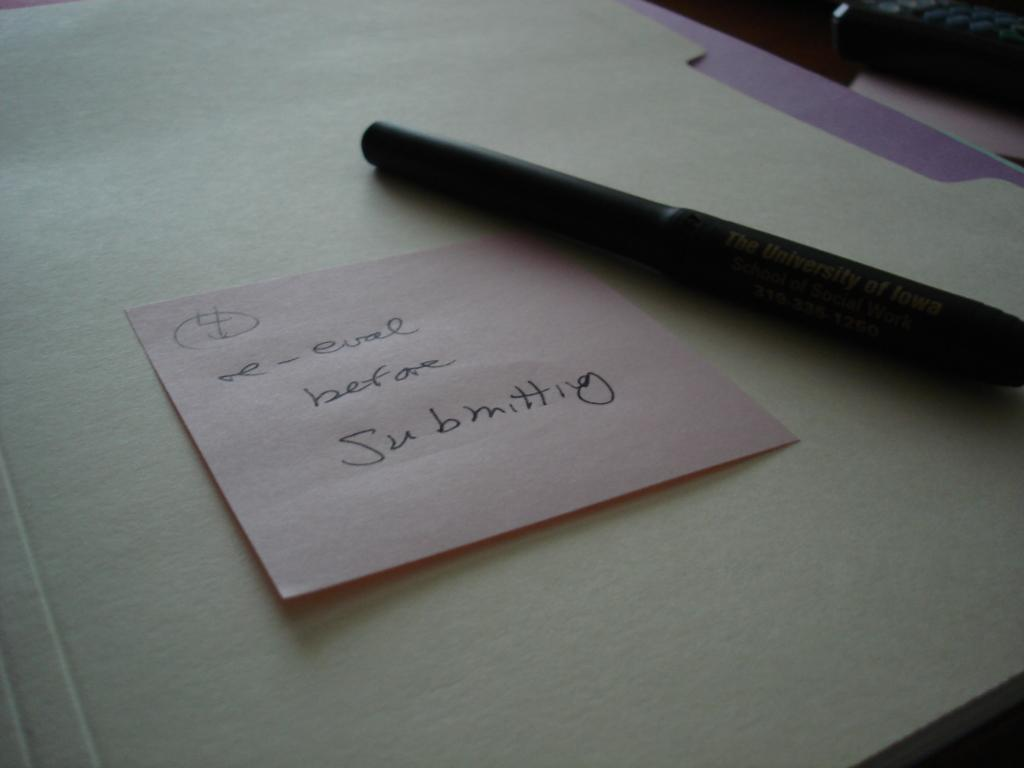What is written on the paper note in the image? The provided facts do not specify the content of the text on the paper note. What object is used for writing in the image? There is a pen in the image. Where are the paper note and pen located in the image? The paper note and pen are placed on a surface. What type of flag is being waved by the organization in the image? There is no flag or organization present in the image; it only features a paper note and a pen. 